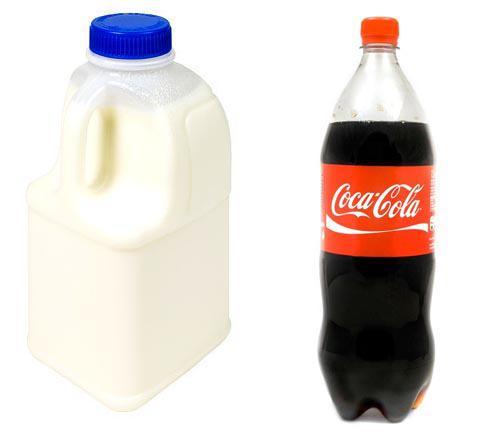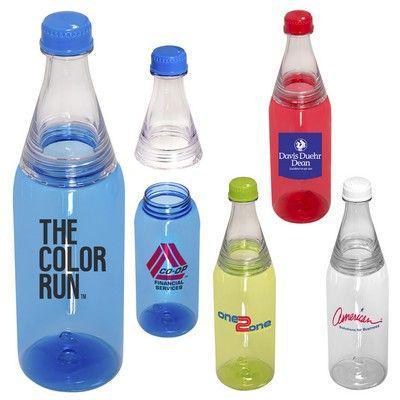The first image is the image on the left, the second image is the image on the right. Analyze the images presented: Is the assertion "No image includes a label with printing on it, and one image contains a straight row of at least four bottles of different colored liquids." valid? Answer yes or no. No. The first image is the image on the left, the second image is the image on the right. Given the left and right images, does the statement "Three 2 liter soda bottles have no labels." hold true? Answer yes or no. No. 